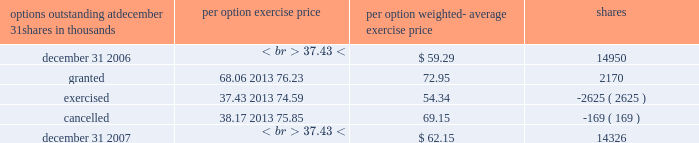Portion of their plan account invested in shares of pnc common stock into other investments available within the plan .
Prior to this amendment , only participants age 50 or older were permitted to exercise this diversification option .
Employee benefits expense related to this plan was $ 52 million in 2007 , $ 52 million in 2006 and $ 47 million in 2005 .
We measured employee benefits expense as the fair value of the shares and cash contributed to the plan by pnc .
Hilliard lyons sponsors a contributory , qualified defined contribution plan that covers substantially all of its employees who are not covered by the plan described above .
Contributions to this plan are made in cash and include a base contribution for those participants employed at december 31 , a matching of employee contributions , and a discretionary profit sharing contribution as determined by hilliard lyons 2019 executive compensation committee .
Employee benefits expense for this plan was $ 6 million in 2007 , $ 5 million in 2006 and $ 6 million in 2005 .
See note 2 acquisitions and divestitures regarding our pending sale of hilliard lyons .
We have a separate qualified defined contribution plan that covers substantially all us-based pfpc employees not covered by our plan .
The plan is a 401 ( k ) plan and includes an esop feature .
Under this plan , employee contributions of up to 6% ( 6 % ) of eligible compensation as defined by the plan may be matched annually based on pfpc performance levels .
Participants must be employed as of december 31 of each year to receive this annual contribution .
The performance- based employer matching contribution will be made primarily in shares of pnc common stock held in treasury , except in the case of those participants who have exercised their diversification election rights to have their matching portion in other investments available within the plan .
Mandatory employer contributions to this plan are made in cash and include employer basic and transitional contributions .
Employee-directed contributions are invested in a number of investment options available under the plan , including a pnc common stock fund and several blackrock mutual funds , at the direction of the employee .
Effective november 22 , 2005 , we amended the plan to provide all participants the ability to diversify the matching portion of their plan account invested in shares of pnc common stock into other investments available within the plan .
Prior to this amendment , only participants age 50 or older were permitted to exercise this diversification option .
Employee benefits expense for this plan was $ 10 million in 2007 , $ 9 million in 2006 and $ 12 million in 2005 .
We measured employee benefits expense as the fair value of the shares and cash contributed to the plan .
We also maintain a nonqualified supplemental savings plan for certain employees .
Note 18 stock-based compensation we have long-term incentive award plans ( 201cincentive plans 201d ) that provide for the granting of incentive stock options , nonqualified stock options , stock appreciation rights , incentive shares/performance units , restricted stock , restricted share units , other share-based awards and dollar-denominated awards to executives and , other than incentive stock options , to non-employee directors .
Certain incentive plan awards may be paid in stock , cash or a combination of stock and cash .
We grant a substantial portion of our stock-based compensation awards during the first quarter of the year .
As of december 31 , 2007 , no incentive stock options or stock appreciation rights were outstanding .
Nonqualified stock options options are granted at exercise prices not less than the market value of common stock on the grant date .
Generally , options granted since 1999 become exercisable in installments after the grant date .
Options granted prior to 1999 are mainly exercisable 12 months after the grant date .
No option may be exercisable after 10 years from its grant date .
Payment of the option exercise price may be in cash or shares of common stock at market value on the exercise date .
The exercise price may be paid in previously owned shares .
Generally , options granted under the incentive plans vest ratably over a three-year period as long as the grantee remains an employee or , in certain cases , retires from pnc .
For all options granted prior to the adoption of sfas 123r , we recognized compensation expense over the three-year vesting period .
If an employee retired prior to the end of the three- year vesting period , we accelerated the expensing of all unrecognized compensation costs at the retirement date .
As required under sfas 123r , we recognize compensation expense for options granted to retirement-eligible employees after january 1 , 2006 in the period granted , in accordance with the service period provisions of the options .
A summary of stock option activity follows: .

What was the net change in stock options outstanding for 2007? 
Computations: (14950 - 14326)
Answer: 624.0. 